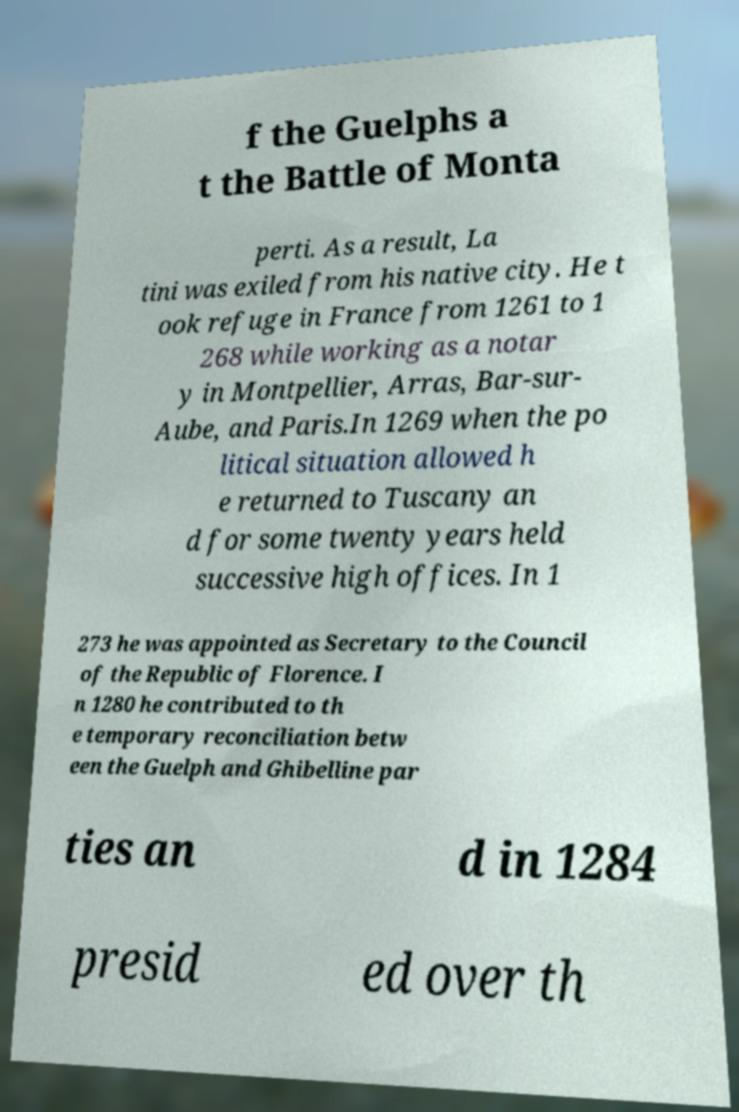Could you extract and type out the text from this image? f the Guelphs a t the Battle of Monta perti. As a result, La tini was exiled from his native city. He t ook refuge in France from 1261 to 1 268 while working as a notar y in Montpellier, Arras, Bar-sur- Aube, and Paris.In 1269 when the po litical situation allowed h e returned to Tuscany an d for some twenty years held successive high offices. In 1 273 he was appointed as Secretary to the Council of the Republic of Florence. I n 1280 he contributed to th e temporary reconciliation betw een the Guelph and Ghibelline par ties an d in 1284 presid ed over th 